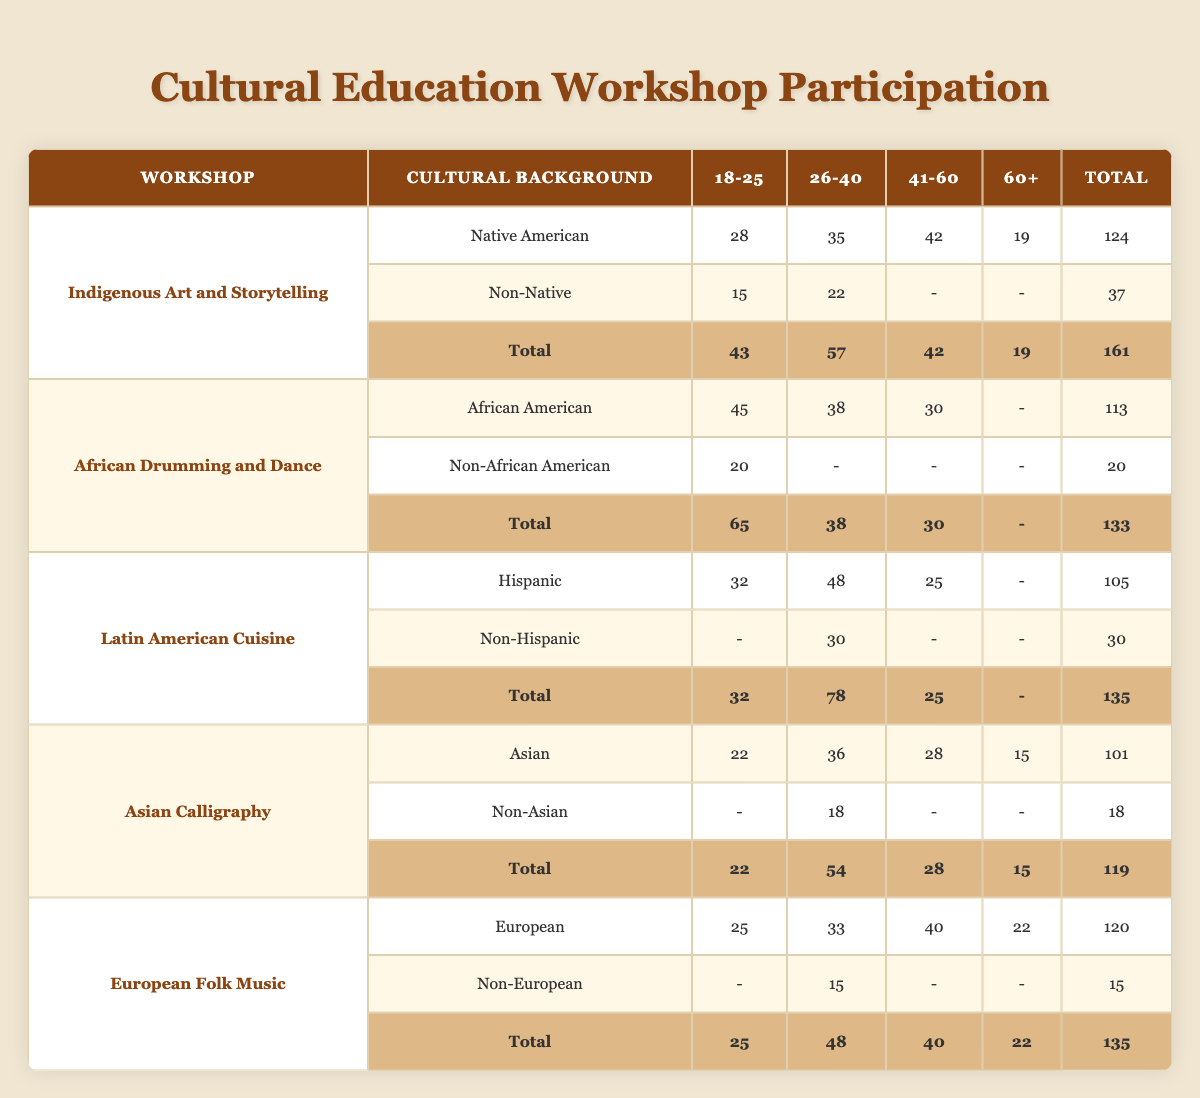What is the total participation in the "African Drumming and Dance" workshop? The total participation can be found in the last row of the "African Drumming and Dance" section. It lists a total of 133 participants.
Answer: 133 How many participants aged 60 and above attended the "European Folk Music" workshop? In the "European Folk Music" section, the row for "European" indicates 22 participants aged 60 and above. The "Non-European" row does not have any participants in this age group, so the total for this workshop is also 22.
Answer: 22 Is there any participant in the "Indigenous Art and Storytelling" workshop from the 41-60 age group who has a non-Native cultural background? In the "Indigenous Art and Storytelling" section, the row for "Non-Native" indicates that there are no participants in the 41-60 age group (marked as "-"), so the answer is no.
Answer: No What is the average number of participants per age group for the "Latin American Cuisine" workshop? For the "Latin American Cuisine" workshop, the age groups have the following participants: 32 (18-25), 48 (26-40), 25 (41-60), and no participants (60+ marked as "-"). The sum is 32 + 48 + 25 + 0 = 105 across 3 age groups (the 60+ group is excluded), giving an average of 105/3 = 35.
Answer: 35 Which workshop has the highest number of participants from the 26-40 age group? By scanning the "26-40" column across all workshops, the highest number of participants is 48, which is for the "Latin American Cuisine" workshop.
Answer: Latin American Cuisine What is the total participation of all workshops for the age group 18-25? To find this, we need to add the participants from each workshop for the age group 18-25: 43 (Indigenous Art and Storytelling) + 45 (African Drumming and Dance) + 32 (Latin American Cuisine) + 22 (Asian Calligraphy) + 25 (European Folk Music) = 167 total participants.
Answer: 167 Are there more participants from the 41-60 age group or the 60+ age group across all workshops? By comparing the total of each age group, the 41-60 age group has: 42 (Indigenous Art and Storytelling) + 30 (African Drumming and Dance) + 25 (Latin American Cuisine) + 28 (Asian Calligraphy) + 40 (European Folk Music) = 165. The 60+ group totals are 19 (Indigenous Art and Storytelling) + 0 (African Drumming and Dance) + 0 (Latin American Cuisine) + 15 (Asian Calligraphy) + 22 (European Folk Music) = 56. Thus, there are more participants in the 41-60 age group.
Answer: Yes Which cultural background group has the least participation in the "Asian Calligraphy" workshop? In the "Asian Calligraphy" workshop, the "Non-Asian" cultural background has 18 participants, while the "Asian" cultural background has 101 participants. Therefore, the group with the least participation is "Non-Asian".
Answer: Non-Asian What is the difference in total participation between the "African Drumming and Dance" and "Indigenous Art and Storytelling" workshops? The totals are 133 for "African Drumming and Dance" and 161 for "Indigenous Art and Storytelling". The difference is calculated as 161 - 133 = 28.
Answer: 28 